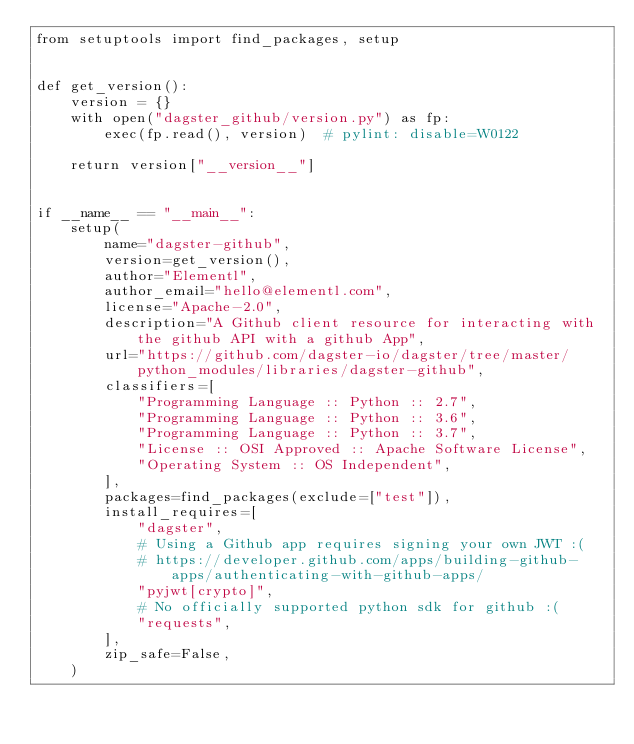<code> <loc_0><loc_0><loc_500><loc_500><_Python_>from setuptools import find_packages, setup


def get_version():
    version = {}
    with open("dagster_github/version.py") as fp:
        exec(fp.read(), version)  # pylint: disable=W0122

    return version["__version__"]


if __name__ == "__main__":
    setup(
        name="dagster-github",
        version=get_version(),
        author="Elementl",
        author_email="hello@elementl.com",
        license="Apache-2.0",
        description="A Github client resource for interacting with the github API with a github App",
        url="https://github.com/dagster-io/dagster/tree/master/python_modules/libraries/dagster-github",
        classifiers=[
            "Programming Language :: Python :: 2.7",
            "Programming Language :: Python :: 3.6",
            "Programming Language :: Python :: 3.7",
            "License :: OSI Approved :: Apache Software License",
            "Operating System :: OS Independent",
        ],
        packages=find_packages(exclude=["test"]),
        install_requires=[
            "dagster",
            # Using a Github app requires signing your own JWT :(
            # https://developer.github.com/apps/building-github-apps/authenticating-with-github-apps/
            "pyjwt[crypto]",
            # No officially supported python sdk for github :(
            "requests",
        ],
        zip_safe=False,
    )
</code> 